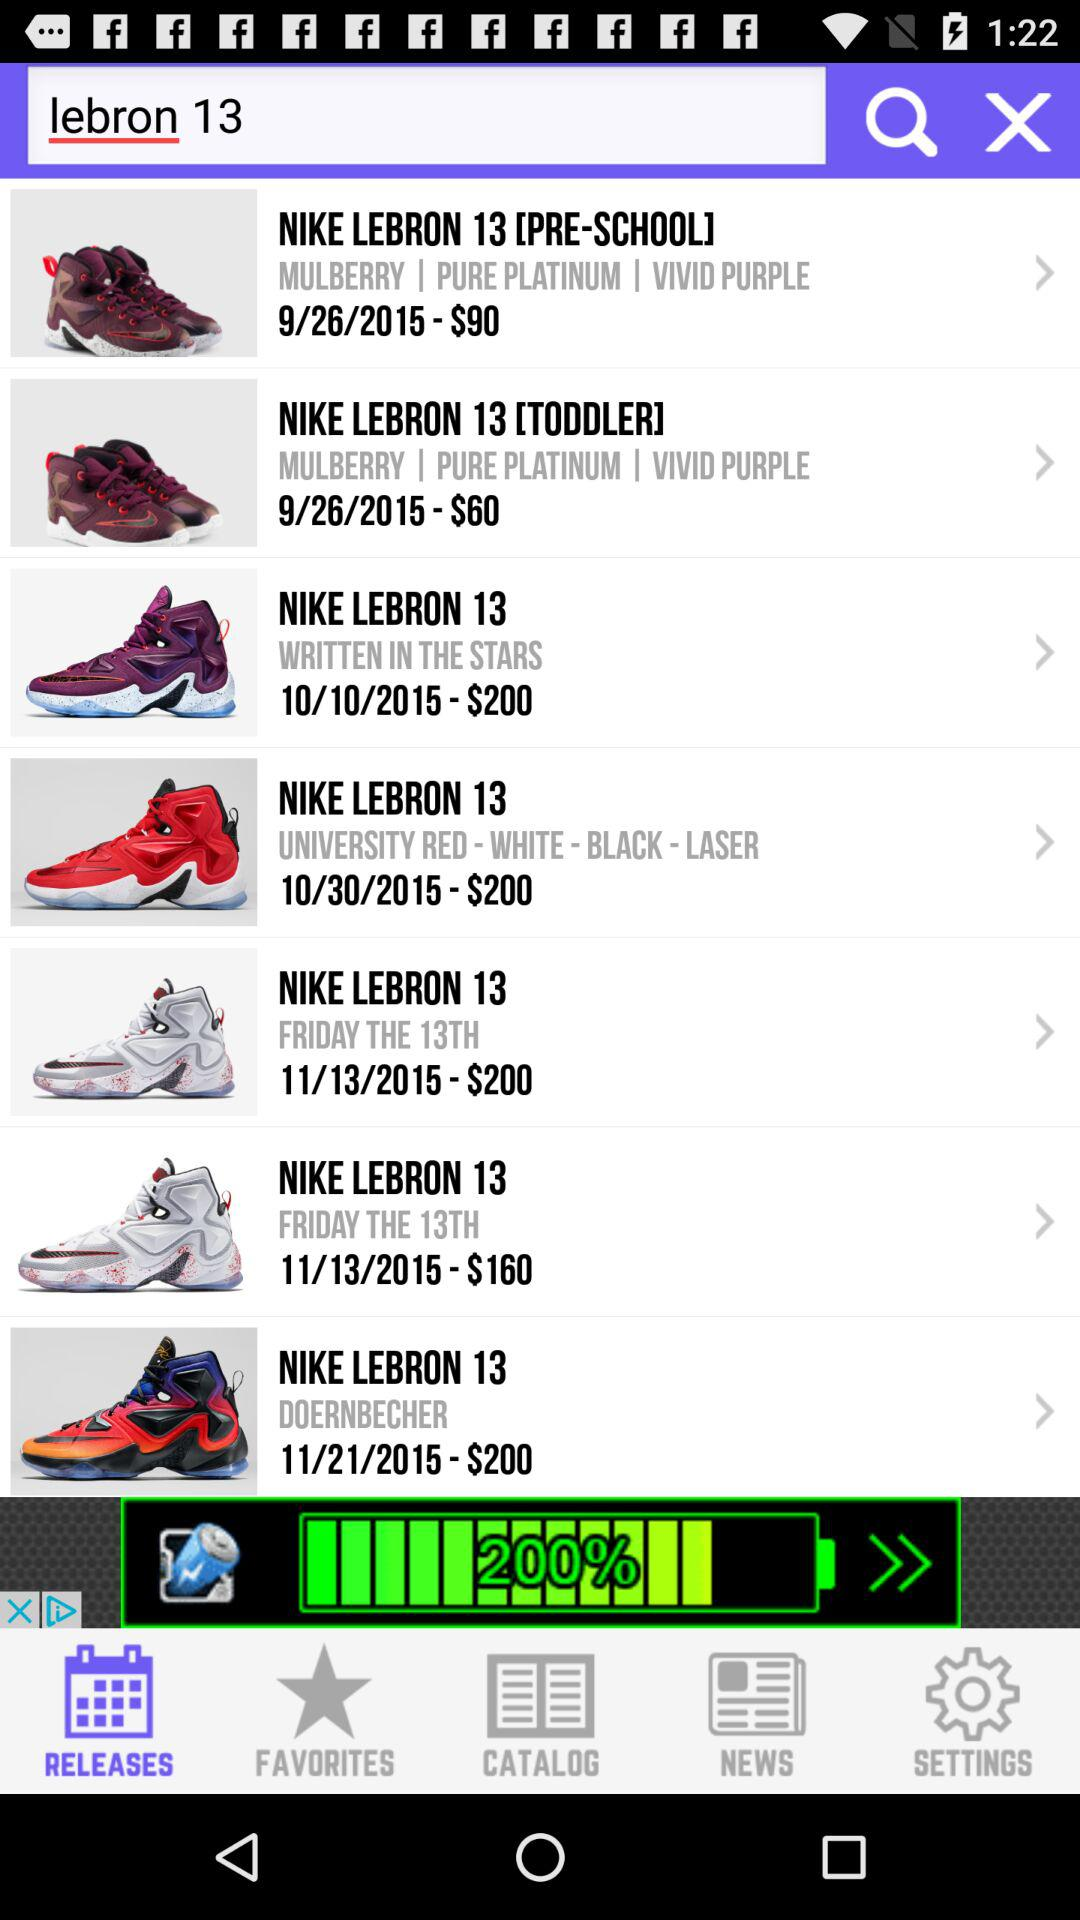What is the price of "NIKE LEBRON 13 [TODDLER]"? The price is $60. 